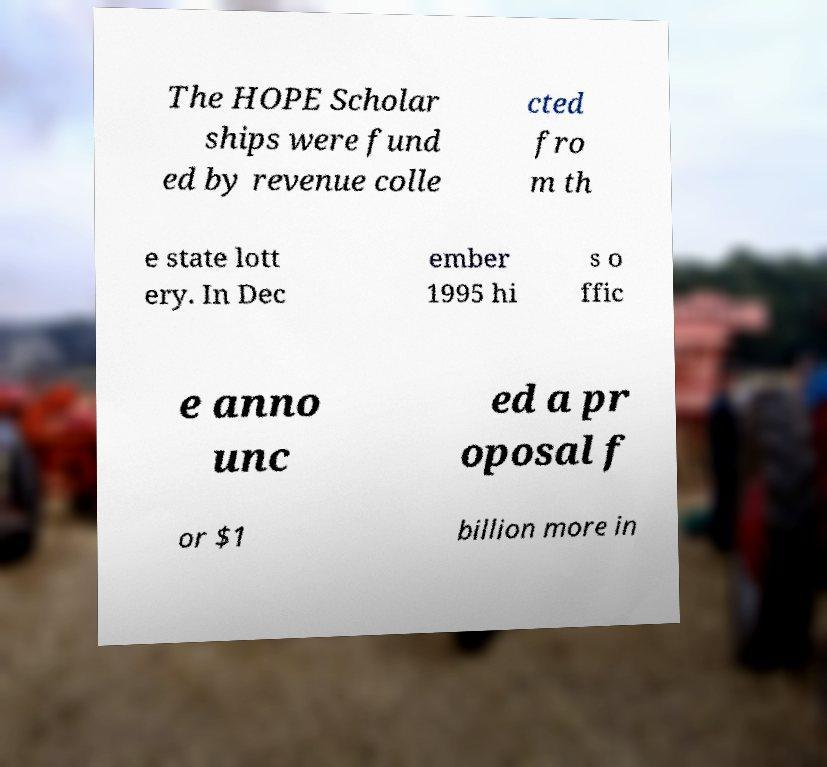Please read and relay the text visible in this image. What does it say? The HOPE Scholar ships were fund ed by revenue colle cted fro m th e state lott ery. In Dec ember 1995 hi s o ffic e anno unc ed a pr oposal f or $1 billion more in 